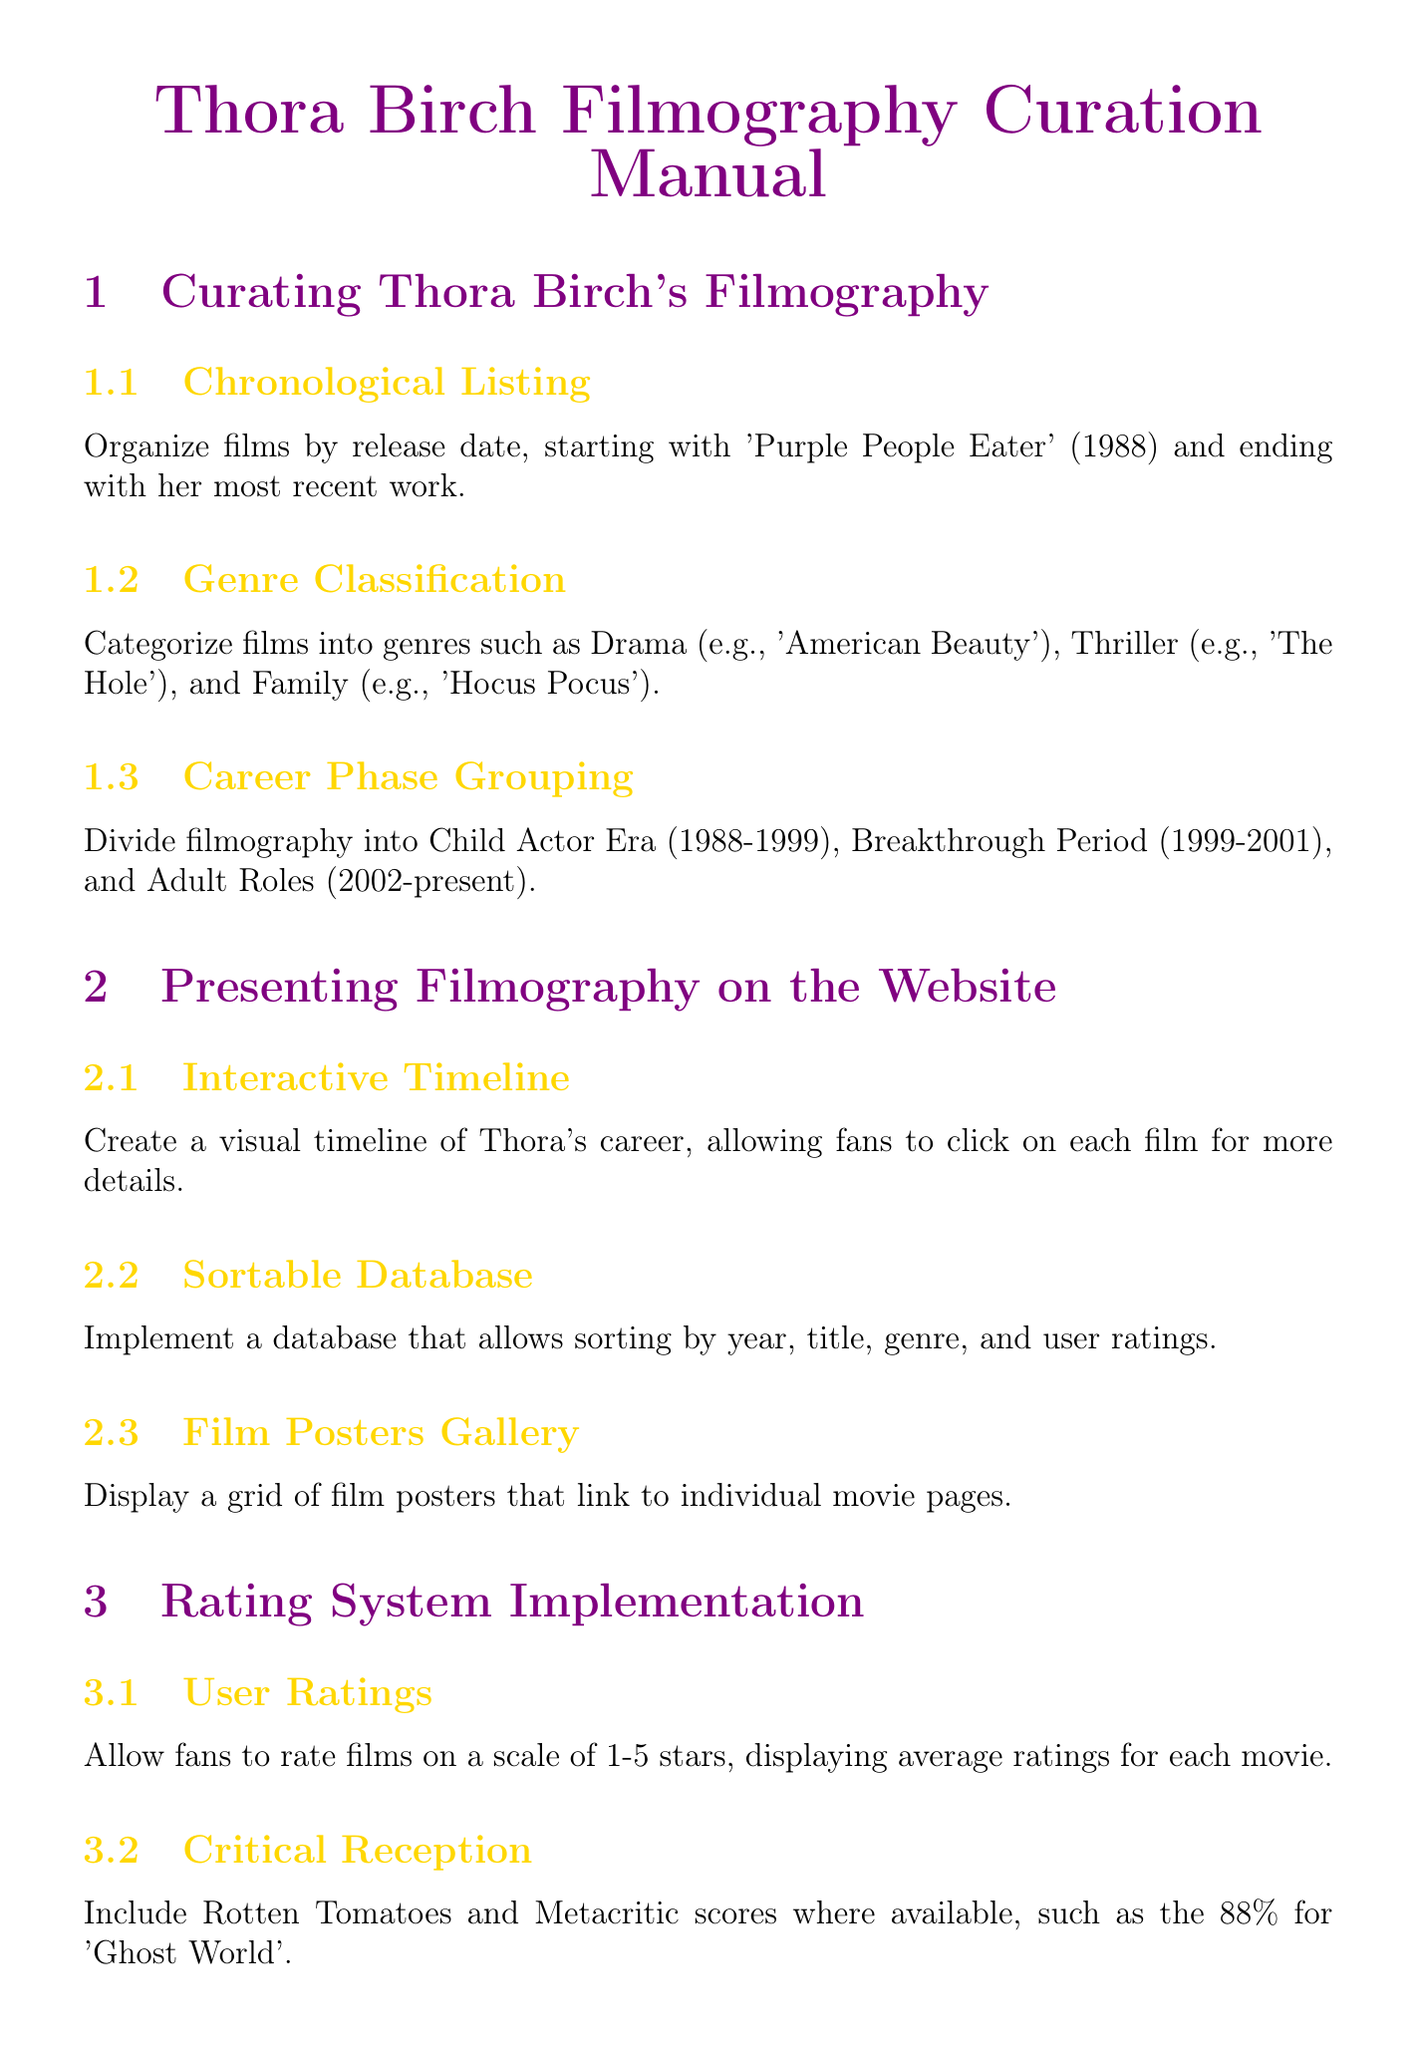What is the first film listed in Thora Birch's filmography? The first film mentioned in the chronological listing is 'Purple People Eater' released in 1988.
Answer: 'Purple People Eater' What genre is 'American Beauty' classified under? 'American Beauty' is classified as a Drama in the genre classification section.
Answer: Drama How many career phases are outlined in the manual? The manual outlines three career phases: Child Actor Era, Breakthrough Period, and Adult Roles.
Answer: Three What feature allows fans to interactively click on films? The interactive timeline allows fans to click on each film for more details.
Answer: Interactive timeline What is the rating scale for user ratings? The user ratings are implemented on a scale of 1-5 stars.
Answer: 1-5 stars Which film has a Rotten Tomatoes score mentioned in the document? The document mentions 'Ghost World' with an 88% Rotten Tomatoes score.
Answer: 'Ghost World' What is one trivia feature suggested for the website? The manual suggests including "Did You Know?" sections to add interesting facts about each film.
Answer: "Did You Know?" sections Which aspect of the website ensures accessibility on mobile devices? The mobile responsiveness ensures the filmography section is easily navigable on mobile devices.
Answer: Mobile responsiveness What is one type of fan engagement feature mentioned? One fan engagement feature is the creation of monthly polls for voting on favorite performances.
Answer: Favorite Films Poll 